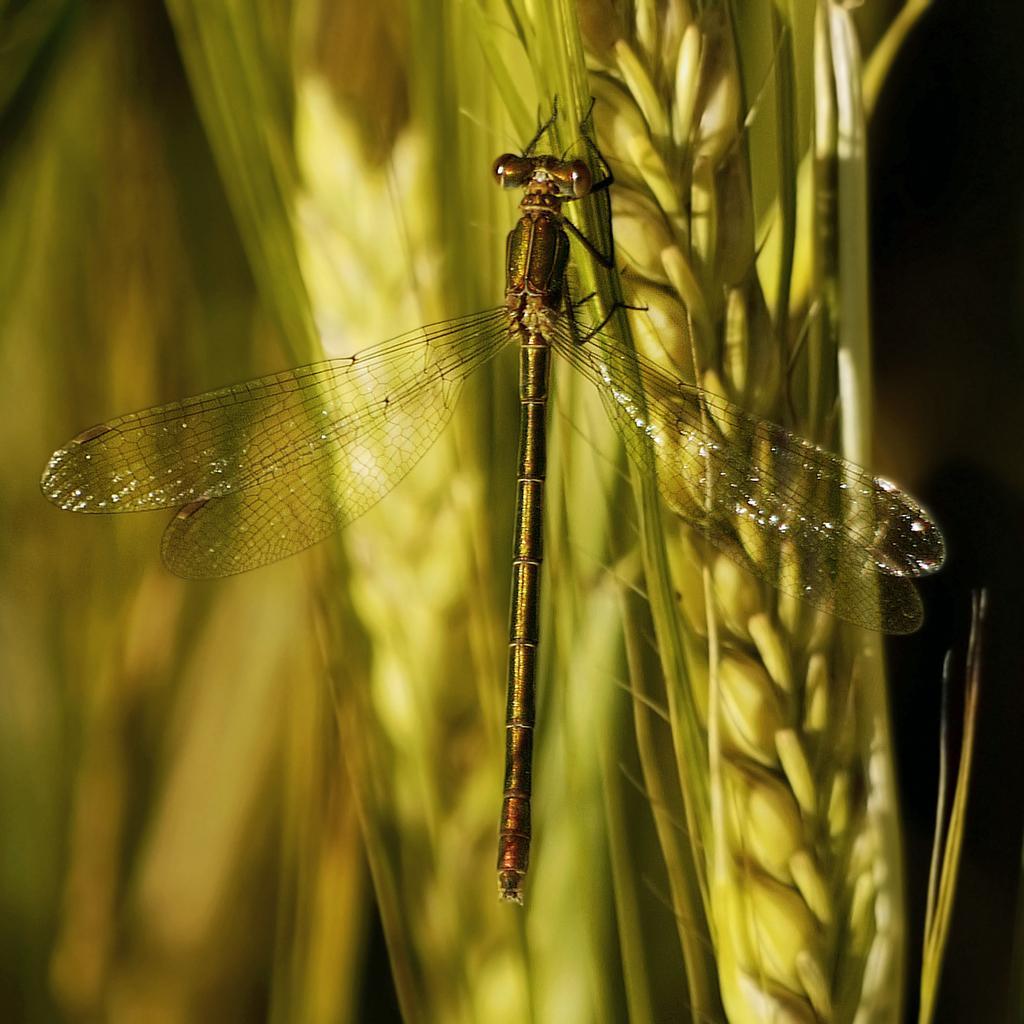Can you describe this image briefly? In the picture there is a dragon fly to a crop and the background of the fly is blur. 